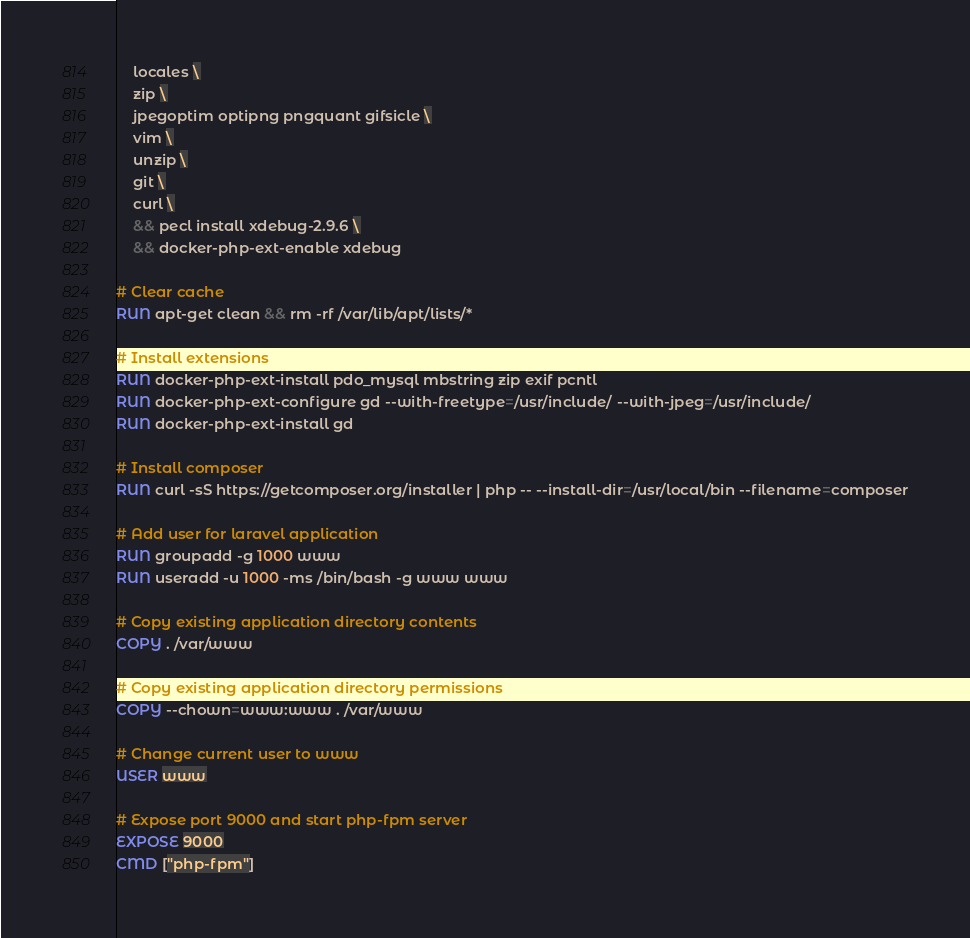Convert code to text. <code><loc_0><loc_0><loc_500><loc_500><_Dockerfile_>    locales \
    zip \
    jpegoptim optipng pngquant gifsicle \
    vim \
    unzip \
    git \
    curl \
    && pecl install xdebug-2.9.6 \
    && docker-php-ext-enable xdebug

# Clear cache
RUN apt-get clean && rm -rf /var/lib/apt/lists/*

# Install extensions
RUN docker-php-ext-install pdo_mysql mbstring zip exif pcntl
RUN docker-php-ext-configure gd --with-freetype=/usr/include/ --with-jpeg=/usr/include/
RUN docker-php-ext-install gd

# Install composer
RUN curl -sS https://getcomposer.org/installer | php -- --install-dir=/usr/local/bin --filename=composer

# Add user for laravel application
RUN groupadd -g 1000 www
RUN useradd -u 1000 -ms /bin/bash -g www www

# Copy existing application directory contents
COPY . /var/www

# Copy existing application directory permissions
COPY --chown=www:www . /var/www

# Change current user to www
USER www

# Expose port 9000 and start php-fpm server
EXPOSE 9000
CMD ["php-fpm"]
</code> 